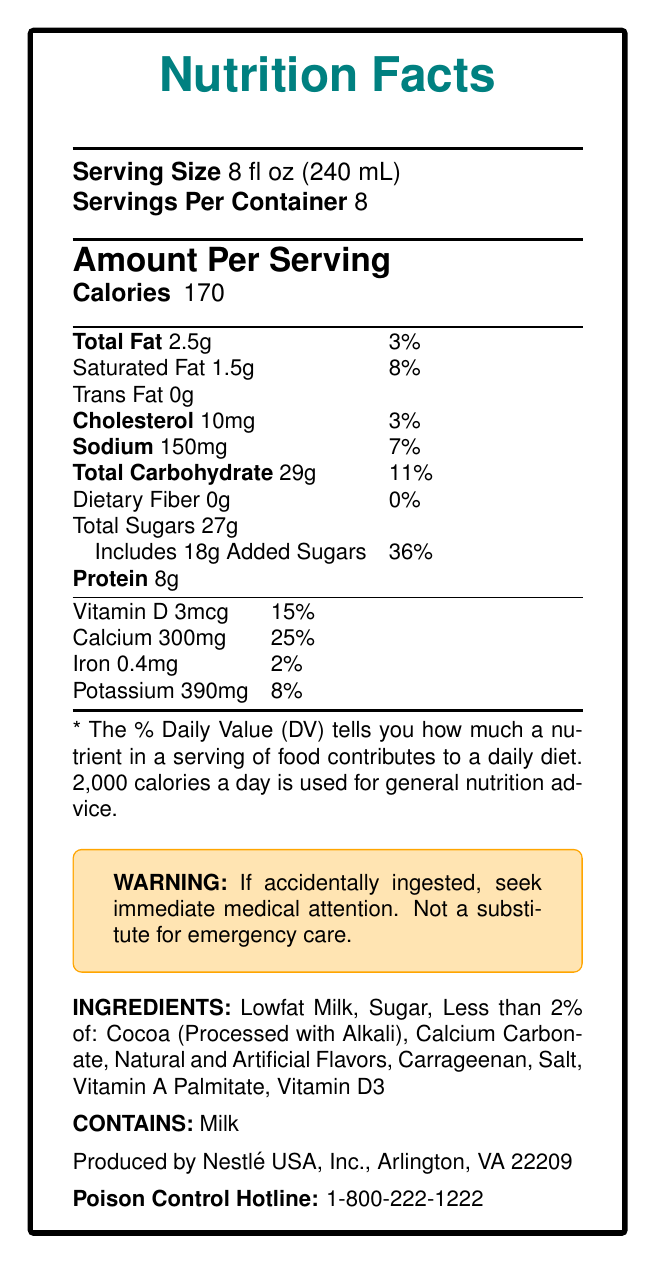what is the serving size? The serving size is mentioned at the top of the document under "Serving Size" which is 8 fl oz (240 mL).
Answer: 8 fl oz (240 mL) how many servings are there per container? The number of servings per container is specified as "Servings Per Container" which is 8.
Answer: 8 how many calories are there per serving? The calorie information is listed under "Amount Per Serving" as 170 calories per serving.
Answer: 170 what percentage of the daily value is the total fat per serving? The total fat percentage of the daily value per serving is given under "Total Fat" which is 3%.
Answer: 3% how much added sugar is in each serving? The "Includes 18g Added Sugars" specifies the amount of added sugar in each serving.
Answer: 18g which of the following nutrients provides the highest percentage of the daily value per serving? A. Vitamin D B. Iron C. Calcium D. Sodium The document shows that Calcium provides 25% of the daily value per serving, which is higher than the other listed nutrients: Vitamin D (15%), Iron (2%), Sodium (7%).
Answer: C. Calcium which ingredient is present in the highest quantity in Nesquik Chocolate Milk? A. Sugar B. Cocoa C. Lowfat Milk D. Carrageenan The ingredients list states "Lowfat Milk" first, indicating it is the primary ingredient.
Answer: C. Lowfat Milk does Nesquik Chocolate Milk contain any trans fat? The "Trans Fat 0g" line indicates there are 0 grams of trans fat per serving.
Answer: No what should someone do if they accidentally ingest the product? The warning box at the bottom specifies that immediate medical attention should be sought if the product is accidentally ingested.
Answer: Seek immediate medical attention what is the contact number for emergency help? The "Poison Control Hotline" section provides the contact number as 1-800-222-1222.
Answer: 1-800-222-1222 summarize the document. The document is a comprehensive nutritional label for Nesquik Chocolate Milk highlighting its nutritional contents, ingredients, and safety information.
Answer: The document provides the nutrition facts for Nesquik Chocolate Milk, including serving size (8 fl oz), servings per container (8), and detailed nutritional information such as calories, fat, cholesterol, sodium, carbohydrates, sugars, proteins, vitamins, and minerals per serving. It also includes ingredients, allergen information, a warning statement, manufacturer information, and an emergency contact number. who is the CEO of Nestlé USA, Inc.? The document only provides the manufacturer information as Nestlé USA, Inc., Arlington, VA 22209, but does not mention the CEO.
Answer: Not enough information what is the total carbohydrate percentage of the daily value per serving? The total carbohydrate percentage of the daily value per serving is listed as "11%" under "Total Carbohydrate".
Answer: 11% is this product suitable for someone with a milk allergy? The allergen information clearly states "Contains: Milk" indicating it is not suitable for someone with a milk allergy.
Answer: No 